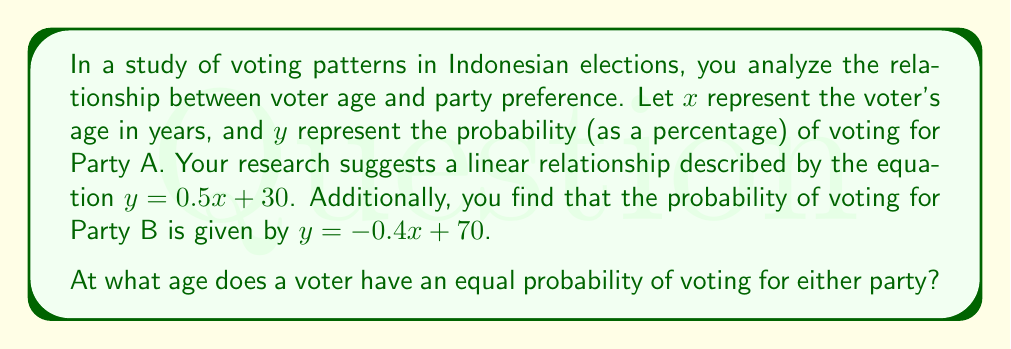Provide a solution to this math problem. To solve this problem, we need to find the point where the probabilities of voting for Party A and Party B are equal. This occurs when the two equations intersect.

Step 1: Set up the system of equations
$$\begin{align}
y &= 0.5x + 30 \quad \text{(Party A)}\\
y &= -0.4x + 70 \quad \text{(Party B)}
\end{align}$$

Step 2: Since we're looking for the point where these probabilities are equal, we can set the right-hand sides of these equations equal to each other:
$$0.5x + 30 = -0.4x + 70$$

Step 3: Solve for x
$$\begin{align}
0.5x + 30 &= -0.4x + 70\\
0.5x + 0.4x &= 70 - 30\\
0.9x &= 40\\
x &= \frac{40}{0.9} \approx 44.44
\end{align}$$

Step 4: Round to the nearest whole number, as age is typically expressed in whole years
$$x \approx 44 \text{ years}$$

Therefore, a voter has an equal probability of voting for either party at approximately 44 years of age.
Answer: 44 years 